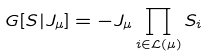Convert formula to latex. <formula><loc_0><loc_0><loc_500><loc_500>G [ S | J _ { \mu } ] = - J _ { \mu } \prod _ { i \in \mathcal { L } ( \mu ) } S _ { i }</formula> 